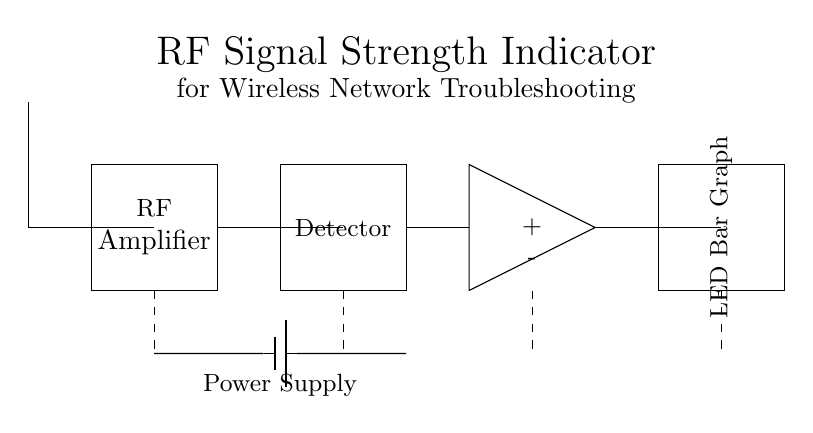What type of amplifier is used in this circuit? The circuit includes an RF amplifier, which is specifically designed to amplify radio frequency signals. This is indicated in the diagram where the amplifier is labeled as "RF Amplifier."
Answer: RF amplifier What is the purpose of the LED bar graph in this circuit? The LED bar graph visually indicates the strength of the RF signal detected, providing an easy way for users to assess signal strength at a glance. This is inferred from the labeling of the component in the circuit.
Answer: Signal strength indication How many main components are there in this RF signal strength indicator circuit? The circuit consists of five main components: the antenna, RF amplifier, detector, op-amp, and LED bar graph. This can be counted directly from the components represented in the diagram.
Answer: Five What does the power supply in the circuit provide? The power supply provides the necessary voltage and current to operate the entire circuit. It connects to multiple components, indicating that they require external power for functionality.
Answer: Voltage and current What type of device is this circuit primarily intended for? This circuit is designed for wireless network troubleshooting, as indicated by the title at the top of the diagram. It specifically caters to assessing and improving wireless network signal strength.
Answer: Wireless network troubleshooting Which component detects the RF signals in the circuit? The component labeled "Detector" is responsible for detecting RF signals. Its position in the circuit is directly after the RF amplifier, indicating it monitors the amplified signals.
Answer: Detector What is the configuration of the operational amplifier in this circuit? The operational amplifier is configured in a differential setup, having both positive and negative inputs labeled. This configuration allows it to process the detected signals effectively.
Answer: Differential setup 